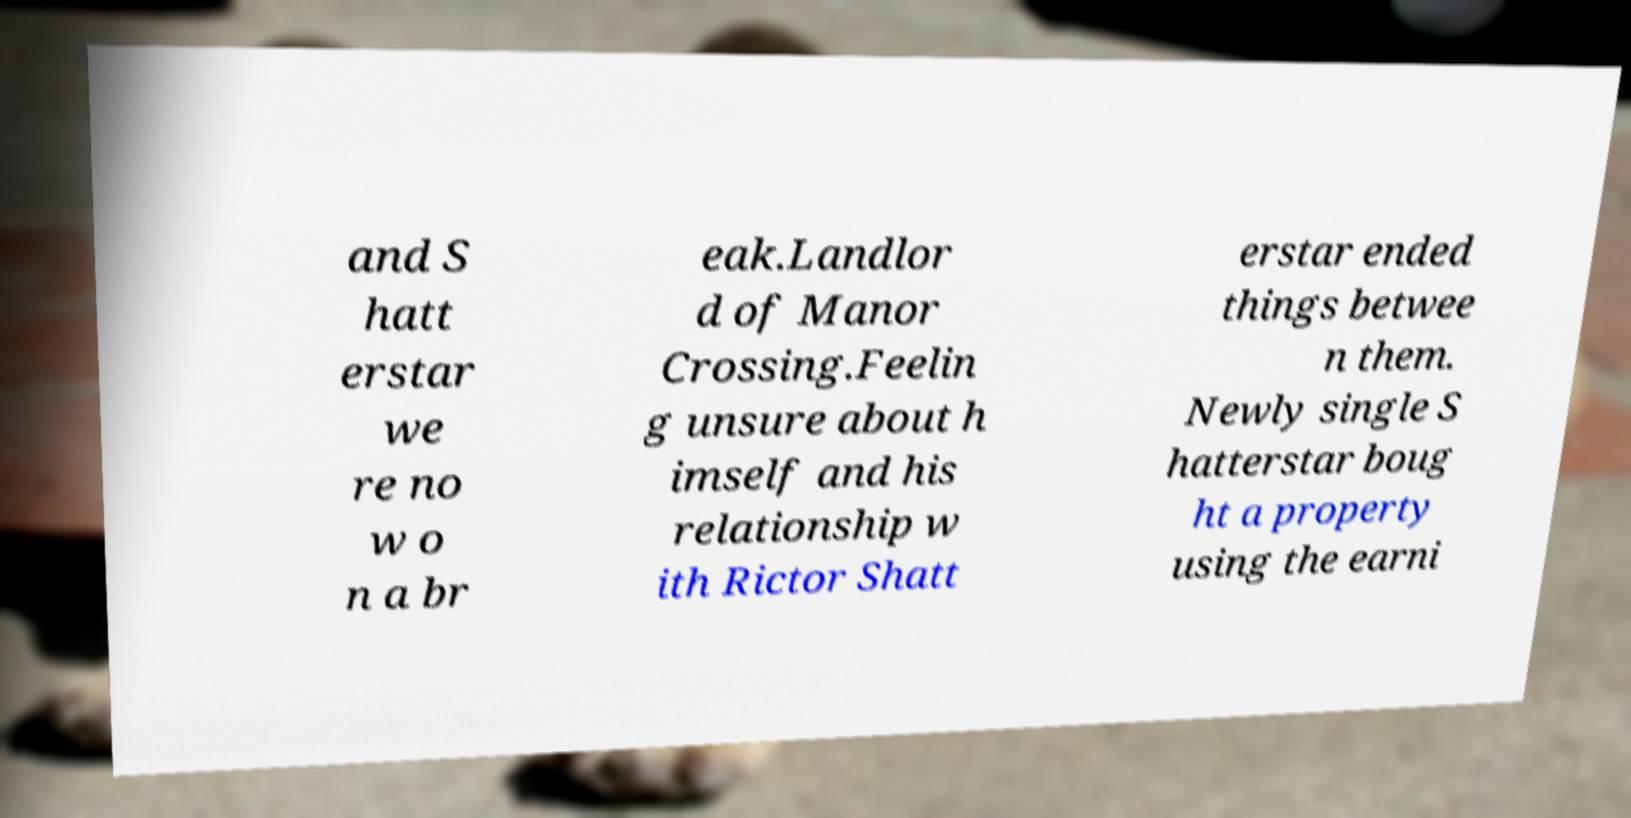For documentation purposes, I need the text within this image transcribed. Could you provide that? and S hatt erstar we re no w o n a br eak.Landlor d of Manor Crossing.Feelin g unsure about h imself and his relationship w ith Rictor Shatt erstar ended things betwee n them. Newly single S hatterstar boug ht a property using the earni 